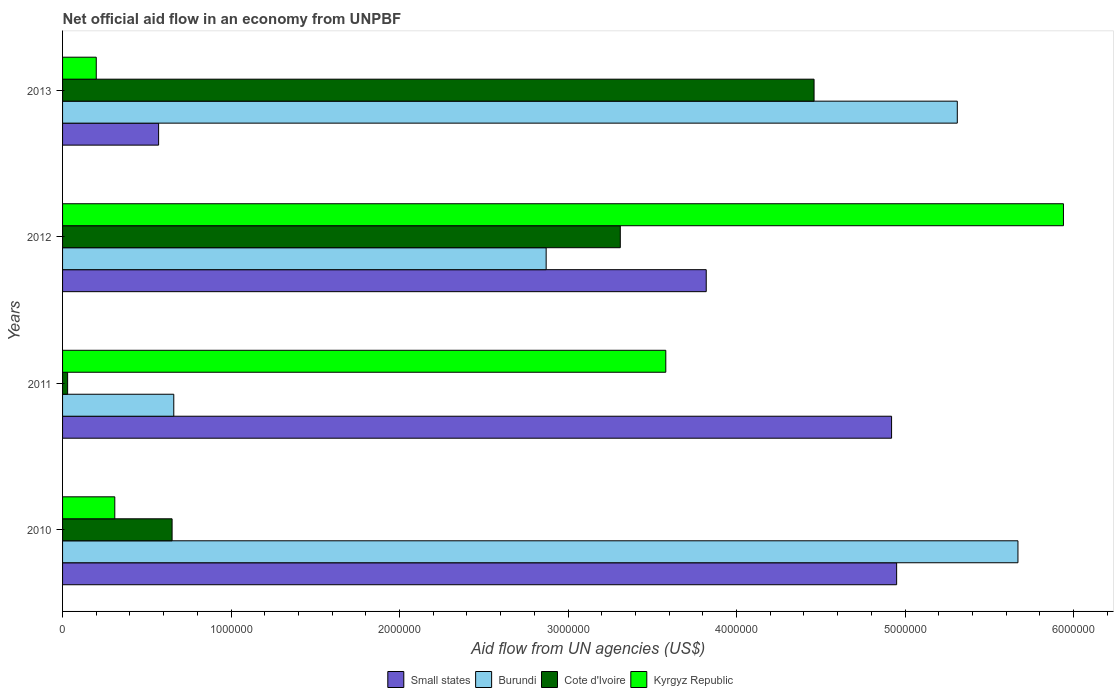How many different coloured bars are there?
Ensure brevity in your answer.  4. Are the number of bars on each tick of the Y-axis equal?
Offer a very short reply. Yes. In how many cases, is the number of bars for a given year not equal to the number of legend labels?
Give a very brief answer. 0. What is the net official aid flow in Burundi in 2012?
Offer a terse response. 2.87e+06. Across all years, what is the maximum net official aid flow in Kyrgyz Republic?
Provide a succinct answer. 5.94e+06. Across all years, what is the minimum net official aid flow in Small states?
Make the answer very short. 5.70e+05. In which year was the net official aid flow in Kyrgyz Republic maximum?
Make the answer very short. 2012. What is the total net official aid flow in Cote d'Ivoire in the graph?
Your answer should be compact. 8.45e+06. What is the difference between the net official aid flow in Cote d'Ivoire in 2010 and that in 2012?
Your answer should be very brief. -2.66e+06. What is the difference between the net official aid flow in Kyrgyz Republic in 2011 and the net official aid flow in Burundi in 2013?
Your answer should be very brief. -1.73e+06. What is the average net official aid flow in Burundi per year?
Your answer should be compact. 3.63e+06. In the year 2012, what is the difference between the net official aid flow in Cote d'Ivoire and net official aid flow in Burundi?
Provide a short and direct response. 4.40e+05. What is the ratio of the net official aid flow in Burundi in 2010 to that in 2012?
Your answer should be compact. 1.98. Is the net official aid flow in Small states in 2010 less than that in 2013?
Provide a succinct answer. No. What is the difference between the highest and the lowest net official aid flow in Cote d'Ivoire?
Offer a very short reply. 4.43e+06. In how many years, is the net official aid flow in Small states greater than the average net official aid flow in Small states taken over all years?
Ensure brevity in your answer.  3. Is the sum of the net official aid flow in Kyrgyz Republic in 2011 and 2013 greater than the maximum net official aid flow in Cote d'Ivoire across all years?
Offer a very short reply. No. Is it the case that in every year, the sum of the net official aid flow in Kyrgyz Republic and net official aid flow in Small states is greater than the sum of net official aid flow in Cote d'Ivoire and net official aid flow in Burundi?
Your answer should be compact. No. What does the 4th bar from the top in 2012 represents?
Make the answer very short. Small states. What does the 2nd bar from the bottom in 2012 represents?
Give a very brief answer. Burundi. What is the difference between two consecutive major ticks on the X-axis?
Provide a short and direct response. 1.00e+06. Are the values on the major ticks of X-axis written in scientific E-notation?
Keep it short and to the point. No. Does the graph contain grids?
Your answer should be compact. No. How are the legend labels stacked?
Offer a terse response. Horizontal. What is the title of the graph?
Your answer should be very brief. Net official aid flow in an economy from UNPBF. Does "Mali" appear as one of the legend labels in the graph?
Give a very brief answer. No. What is the label or title of the X-axis?
Your answer should be compact. Aid flow from UN agencies (US$). What is the label or title of the Y-axis?
Provide a short and direct response. Years. What is the Aid flow from UN agencies (US$) of Small states in 2010?
Your response must be concise. 4.95e+06. What is the Aid flow from UN agencies (US$) in Burundi in 2010?
Give a very brief answer. 5.67e+06. What is the Aid flow from UN agencies (US$) of Cote d'Ivoire in 2010?
Provide a succinct answer. 6.50e+05. What is the Aid flow from UN agencies (US$) of Small states in 2011?
Provide a succinct answer. 4.92e+06. What is the Aid flow from UN agencies (US$) of Burundi in 2011?
Give a very brief answer. 6.60e+05. What is the Aid flow from UN agencies (US$) in Kyrgyz Republic in 2011?
Provide a succinct answer. 3.58e+06. What is the Aid flow from UN agencies (US$) of Small states in 2012?
Your answer should be very brief. 3.82e+06. What is the Aid flow from UN agencies (US$) in Burundi in 2012?
Offer a terse response. 2.87e+06. What is the Aid flow from UN agencies (US$) in Cote d'Ivoire in 2012?
Offer a terse response. 3.31e+06. What is the Aid flow from UN agencies (US$) of Kyrgyz Republic in 2012?
Your answer should be very brief. 5.94e+06. What is the Aid flow from UN agencies (US$) of Small states in 2013?
Ensure brevity in your answer.  5.70e+05. What is the Aid flow from UN agencies (US$) in Burundi in 2013?
Provide a succinct answer. 5.31e+06. What is the Aid flow from UN agencies (US$) of Cote d'Ivoire in 2013?
Ensure brevity in your answer.  4.46e+06. What is the Aid flow from UN agencies (US$) in Kyrgyz Republic in 2013?
Keep it short and to the point. 2.00e+05. Across all years, what is the maximum Aid flow from UN agencies (US$) of Small states?
Offer a very short reply. 4.95e+06. Across all years, what is the maximum Aid flow from UN agencies (US$) in Burundi?
Your response must be concise. 5.67e+06. Across all years, what is the maximum Aid flow from UN agencies (US$) of Cote d'Ivoire?
Offer a terse response. 4.46e+06. Across all years, what is the maximum Aid flow from UN agencies (US$) of Kyrgyz Republic?
Offer a very short reply. 5.94e+06. Across all years, what is the minimum Aid flow from UN agencies (US$) in Small states?
Make the answer very short. 5.70e+05. Across all years, what is the minimum Aid flow from UN agencies (US$) in Burundi?
Your answer should be very brief. 6.60e+05. Across all years, what is the minimum Aid flow from UN agencies (US$) of Cote d'Ivoire?
Your answer should be compact. 3.00e+04. What is the total Aid flow from UN agencies (US$) in Small states in the graph?
Ensure brevity in your answer.  1.43e+07. What is the total Aid flow from UN agencies (US$) in Burundi in the graph?
Make the answer very short. 1.45e+07. What is the total Aid flow from UN agencies (US$) in Cote d'Ivoire in the graph?
Your answer should be very brief. 8.45e+06. What is the total Aid flow from UN agencies (US$) in Kyrgyz Republic in the graph?
Offer a very short reply. 1.00e+07. What is the difference between the Aid flow from UN agencies (US$) of Small states in 2010 and that in 2011?
Provide a short and direct response. 3.00e+04. What is the difference between the Aid flow from UN agencies (US$) of Burundi in 2010 and that in 2011?
Offer a terse response. 5.01e+06. What is the difference between the Aid flow from UN agencies (US$) in Cote d'Ivoire in 2010 and that in 2011?
Provide a succinct answer. 6.20e+05. What is the difference between the Aid flow from UN agencies (US$) in Kyrgyz Republic in 2010 and that in 2011?
Your response must be concise. -3.27e+06. What is the difference between the Aid flow from UN agencies (US$) of Small states in 2010 and that in 2012?
Ensure brevity in your answer.  1.13e+06. What is the difference between the Aid flow from UN agencies (US$) in Burundi in 2010 and that in 2012?
Offer a terse response. 2.80e+06. What is the difference between the Aid flow from UN agencies (US$) of Cote d'Ivoire in 2010 and that in 2012?
Keep it short and to the point. -2.66e+06. What is the difference between the Aid flow from UN agencies (US$) in Kyrgyz Republic in 2010 and that in 2012?
Ensure brevity in your answer.  -5.63e+06. What is the difference between the Aid flow from UN agencies (US$) in Small states in 2010 and that in 2013?
Offer a terse response. 4.38e+06. What is the difference between the Aid flow from UN agencies (US$) in Cote d'Ivoire in 2010 and that in 2013?
Offer a very short reply. -3.81e+06. What is the difference between the Aid flow from UN agencies (US$) of Kyrgyz Republic in 2010 and that in 2013?
Offer a very short reply. 1.10e+05. What is the difference between the Aid flow from UN agencies (US$) in Small states in 2011 and that in 2012?
Your answer should be compact. 1.10e+06. What is the difference between the Aid flow from UN agencies (US$) of Burundi in 2011 and that in 2012?
Your answer should be very brief. -2.21e+06. What is the difference between the Aid flow from UN agencies (US$) of Cote d'Ivoire in 2011 and that in 2012?
Your answer should be very brief. -3.28e+06. What is the difference between the Aid flow from UN agencies (US$) of Kyrgyz Republic in 2011 and that in 2012?
Your answer should be very brief. -2.36e+06. What is the difference between the Aid flow from UN agencies (US$) in Small states in 2011 and that in 2013?
Provide a succinct answer. 4.35e+06. What is the difference between the Aid flow from UN agencies (US$) in Burundi in 2011 and that in 2013?
Ensure brevity in your answer.  -4.65e+06. What is the difference between the Aid flow from UN agencies (US$) in Cote d'Ivoire in 2011 and that in 2013?
Your response must be concise. -4.43e+06. What is the difference between the Aid flow from UN agencies (US$) in Kyrgyz Republic in 2011 and that in 2013?
Offer a terse response. 3.38e+06. What is the difference between the Aid flow from UN agencies (US$) of Small states in 2012 and that in 2013?
Provide a succinct answer. 3.25e+06. What is the difference between the Aid flow from UN agencies (US$) of Burundi in 2012 and that in 2013?
Make the answer very short. -2.44e+06. What is the difference between the Aid flow from UN agencies (US$) in Cote d'Ivoire in 2012 and that in 2013?
Give a very brief answer. -1.15e+06. What is the difference between the Aid flow from UN agencies (US$) in Kyrgyz Republic in 2012 and that in 2013?
Your response must be concise. 5.74e+06. What is the difference between the Aid flow from UN agencies (US$) in Small states in 2010 and the Aid flow from UN agencies (US$) in Burundi in 2011?
Your answer should be very brief. 4.29e+06. What is the difference between the Aid flow from UN agencies (US$) of Small states in 2010 and the Aid flow from UN agencies (US$) of Cote d'Ivoire in 2011?
Your answer should be very brief. 4.92e+06. What is the difference between the Aid flow from UN agencies (US$) of Small states in 2010 and the Aid flow from UN agencies (US$) of Kyrgyz Republic in 2011?
Your answer should be compact. 1.37e+06. What is the difference between the Aid flow from UN agencies (US$) of Burundi in 2010 and the Aid flow from UN agencies (US$) of Cote d'Ivoire in 2011?
Keep it short and to the point. 5.64e+06. What is the difference between the Aid flow from UN agencies (US$) of Burundi in 2010 and the Aid flow from UN agencies (US$) of Kyrgyz Republic in 2011?
Provide a succinct answer. 2.09e+06. What is the difference between the Aid flow from UN agencies (US$) of Cote d'Ivoire in 2010 and the Aid flow from UN agencies (US$) of Kyrgyz Republic in 2011?
Offer a very short reply. -2.93e+06. What is the difference between the Aid flow from UN agencies (US$) in Small states in 2010 and the Aid flow from UN agencies (US$) in Burundi in 2012?
Offer a terse response. 2.08e+06. What is the difference between the Aid flow from UN agencies (US$) in Small states in 2010 and the Aid flow from UN agencies (US$) in Cote d'Ivoire in 2012?
Keep it short and to the point. 1.64e+06. What is the difference between the Aid flow from UN agencies (US$) of Small states in 2010 and the Aid flow from UN agencies (US$) of Kyrgyz Republic in 2012?
Offer a very short reply. -9.90e+05. What is the difference between the Aid flow from UN agencies (US$) in Burundi in 2010 and the Aid flow from UN agencies (US$) in Cote d'Ivoire in 2012?
Provide a succinct answer. 2.36e+06. What is the difference between the Aid flow from UN agencies (US$) in Burundi in 2010 and the Aid flow from UN agencies (US$) in Kyrgyz Republic in 2012?
Provide a short and direct response. -2.70e+05. What is the difference between the Aid flow from UN agencies (US$) in Cote d'Ivoire in 2010 and the Aid flow from UN agencies (US$) in Kyrgyz Republic in 2012?
Make the answer very short. -5.29e+06. What is the difference between the Aid flow from UN agencies (US$) in Small states in 2010 and the Aid flow from UN agencies (US$) in Burundi in 2013?
Your response must be concise. -3.60e+05. What is the difference between the Aid flow from UN agencies (US$) of Small states in 2010 and the Aid flow from UN agencies (US$) of Cote d'Ivoire in 2013?
Make the answer very short. 4.90e+05. What is the difference between the Aid flow from UN agencies (US$) of Small states in 2010 and the Aid flow from UN agencies (US$) of Kyrgyz Republic in 2013?
Keep it short and to the point. 4.75e+06. What is the difference between the Aid flow from UN agencies (US$) of Burundi in 2010 and the Aid flow from UN agencies (US$) of Cote d'Ivoire in 2013?
Provide a succinct answer. 1.21e+06. What is the difference between the Aid flow from UN agencies (US$) in Burundi in 2010 and the Aid flow from UN agencies (US$) in Kyrgyz Republic in 2013?
Keep it short and to the point. 5.47e+06. What is the difference between the Aid flow from UN agencies (US$) of Small states in 2011 and the Aid flow from UN agencies (US$) of Burundi in 2012?
Make the answer very short. 2.05e+06. What is the difference between the Aid flow from UN agencies (US$) of Small states in 2011 and the Aid flow from UN agencies (US$) of Cote d'Ivoire in 2012?
Give a very brief answer. 1.61e+06. What is the difference between the Aid flow from UN agencies (US$) in Small states in 2011 and the Aid flow from UN agencies (US$) in Kyrgyz Republic in 2012?
Provide a succinct answer. -1.02e+06. What is the difference between the Aid flow from UN agencies (US$) in Burundi in 2011 and the Aid flow from UN agencies (US$) in Cote d'Ivoire in 2012?
Provide a short and direct response. -2.65e+06. What is the difference between the Aid flow from UN agencies (US$) in Burundi in 2011 and the Aid flow from UN agencies (US$) in Kyrgyz Republic in 2012?
Your response must be concise. -5.28e+06. What is the difference between the Aid flow from UN agencies (US$) of Cote d'Ivoire in 2011 and the Aid flow from UN agencies (US$) of Kyrgyz Republic in 2012?
Your answer should be compact. -5.91e+06. What is the difference between the Aid flow from UN agencies (US$) of Small states in 2011 and the Aid flow from UN agencies (US$) of Burundi in 2013?
Make the answer very short. -3.90e+05. What is the difference between the Aid flow from UN agencies (US$) of Small states in 2011 and the Aid flow from UN agencies (US$) of Cote d'Ivoire in 2013?
Give a very brief answer. 4.60e+05. What is the difference between the Aid flow from UN agencies (US$) in Small states in 2011 and the Aid flow from UN agencies (US$) in Kyrgyz Republic in 2013?
Provide a short and direct response. 4.72e+06. What is the difference between the Aid flow from UN agencies (US$) in Burundi in 2011 and the Aid flow from UN agencies (US$) in Cote d'Ivoire in 2013?
Offer a terse response. -3.80e+06. What is the difference between the Aid flow from UN agencies (US$) in Cote d'Ivoire in 2011 and the Aid flow from UN agencies (US$) in Kyrgyz Republic in 2013?
Make the answer very short. -1.70e+05. What is the difference between the Aid flow from UN agencies (US$) of Small states in 2012 and the Aid flow from UN agencies (US$) of Burundi in 2013?
Your answer should be very brief. -1.49e+06. What is the difference between the Aid flow from UN agencies (US$) of Small states in 2012 and the Aid flow from UN agencies (US$) of Cote d'Ivoire in 2013?
Your answer should be compact. -6.40e+05. What is the difference between the Aid flow from UN agencies (US$) of Small states in 2012 and the Aid flow from UN agencies (US$) of Kyrgyz Republic in 2013?
Your response must be concise. 3.62e+06. What is the difference between the Aid flow from UN agencies (US$) of Burundi in 2012 and the Aid flow from UN agencies (US$) of Cote d'Ivoire in 2013?
Provide a short and direct response. -1.59e+06. What is the difference between the Aid flow from UN agencies (US$) in Burundi in 2012 and the Aid flow from UN agencies (US$) in Kyrgyz Republic in 2013?
Offer a very short reply. 2.67e+06. What is the difference between the Aid flow from UN agencies (US$) in Cote d'Ivoire in 2012 and the Aid flow from UN agencies (US$) in Kyrgyz Republic in 2013?
Offer a very short reply. 3.11e+06. What is the average Aid flow from UN agencies (US$) of Small states per year?
Offer a very short reply. 3.56e+06. What is the average Aid flow from UN agencies (US$) in Burundi per year?
Keep it short and to the point. 3.63e+06. What is the average Aid flow from UN agencies (US$) in Cote d'Ivoire per year?
Your answer should be very brief. 2.11e+06. What is the average Aid flow from UN agencies (US$) in Kyrgyz Republic per year?
Your answer should be very brief. 2.51e+06. In the year 2010, what is the difference between the Aid flow from UN agencies (US$) in Small states and Aid flow from UN agencies (US$) in Burundi?
Provide a succinct answer. -7.20e+05. In the year 2010, what is the difference between the Aid flow from UN agencies (US$) in Small states and Aid flow from UN agencies (US$) in Cote d'Ivoire?
Offer a very short reply. 4.30e+06. In the year 2010, what is the difference between the Aid flow from UN agencies (US$) of Small states and Aid flow from UN agencies (US$) of Kyrgyz Republic?
Your answer should be very brief. 4.64e+06. In the year 2010, what is the difference between the Aid flow from UN agencies (US$) of Burundi and Aid flow from UN agencies (US$) of Cote d'Ivoire?
Offer a terse response. 5.02e+06. In the year 2010, what is the difference between the Aid flow from UN agencies (US$) of Burundi and Aid flow from UN agencies (US$) of Kyrgyz Republic?
Give a very brief answer. 5.36e+06. In the year 2011, what is the difference between the Aid flow from UN agencies (US$) in Small states and Aid flow from UN agencies (US$) in Burundi?
Provide a succinct answer. 4.26e+06. In the year 2011, what is the difference between the Aid flow from UN agencies (US$) in Small states and Aid flow from UN agencies (US$) in Cote d'Ivoire?
Ensure brevity in your answer.  4.89e+06. In the year 2011, what is the difference between the Aid flow from UN agencies (US$) in Small states and Aid flow from UN agencies (US$) in Kyrgyz Republic?
Give a very brief answer. 1.34e+06. In the year 2011, what is the difference between the Aid flow from UN agencies (US$) of Burundi and Aid flow from UN agencies (US$) of Cote d'Ivoire?
Offer a terse response. 6.30e+05. In the year 2011, what is the difference between the Aid flow from UN agencies (US$) in Burundi and Aid flow from UN agencies (US$) in Kyrgyz Republic?
Offer a terse response. -2.92e+06. In the year 2011, what is the difference between the Aid flow from UN agencies (US$) of Cote d'Ivoire and Aid flow from UN agencies (US$) of Kyrgyz Republic?
Ensure brevity in your answer.  -3.55e+06. In the year 2012, what is the difference between the Aid flow from UN agencies (US$) in Small states and Aid flow from UN agencies (US$) in Burundi?
Your answer should be very brief. 9.50e+05. In the year 2012, what is the difference between the Aid flow from UN agencies (US$) in Small states and Aid flow from UN agencies (US$) in Cote d'Ivoire?
Your answer should be compact. 5.10e+05. In the year 2012, what is the difference between the Aid flow from UN agencies (US$) of Small states and Aid flow from UN agencies (US$) of Kyrgyz Republic?
Your answer should be very brief. -2.12e+06. In the year 2012, what is the difference between the Aid flow from UN agencies (US$) in Burundi and Aid flow from UN agencies (US$) in Cote d'Ivoire?
Offer a terse response. -4.40e+05. In the year 2012, what is the difference between the Aid flow from UN agencies (US$) in Burundi and Aid flow from UN agencies (US$) in Kyrgyz Republic?
Provide a succinct answer. -3.07e+06. In the year 2012, what is the difference between the Aid flow from UN agencies (US$) of Cote d'Ivoire and Aid flow from UN agencies (US$) of Kyrgyz Republic?
Provide a succinct answer. -2.63e+06. In the year 2013, what is the difference between the Aid flow from UN agencies (US$) of Small states and Aid flow from UN agencies (US$) of Burundi?
Your answer should be compact. -4.74e+06. In the year 2013, what is the difference between the Aid flow from UN agencies (US$) of Small states and Aid flow from UN agencies (US$) of Cote d'Ivoire?
Offer a very short reply. -3.89e+06. In the year 2013, what is the difference between the Aid flow from UN agencies (US$) of Burundi and Aid flow from UN agencies (US$) of Cote d'Ivoire?
Give a very brief answer. 8.50e+05. In the year 2013, what is the difference between the Aid flow from UN agencies (US$) in Burundi and Aid flow from UN agencies (US$) in Kyrgyz Republic?
Your answer should be compact. 5.11e+06. In the year 2013, what is the difference between the Aid flow from UN agencies (US$) of Cote d'Ivoire and Aid flow from UN agencies (US$) of Kyrgyz Republic?
Provide a short and direct response. 4.26e+06. What is the ratio of the Aid flow from UN agencies (US$) in Small states in 2010 to that in 2011?
Provide a short and direct response. 1.01. What is the ratio of the Aid flow from UN agencies (US$) in Burundi in 2010 to that in 2011?
Your answer should be compact. 8.59. What is the ratio of the Aid flow from UN agencies (US$) of Cote d'Ivoire in 2010 to that in 2011?
Offer a very short reply. 21.67. What is the ratio of the Aid flow from UN agencies (US$) of Kyrgyz Republic in 2010 to that in 2011?
Provide a succinct answer. 0.09. What is the ratio of the Aid flow from UN agencies (US$) of Small states in 2010 to that in 2012?
Your answer should be compact. 1.3. What is the ratio of the Aid flow from UN agencies (US$) of Burundi in 2010 to that in 2012?
Make the answer very short. 1.98. What is the ratio of the Aid flow from UN agencies (US$) in Cote d'Ivoire in 2010 to that in 2012?
Your answer should be very brief. 0.2. What is the ratio of the Aid flow from UN agencies (US$) of Kyrgyz Republic in 2010 to that in 2012?
Your answer should be very brief. 0.05. What is the ratio of the Aid flow from UN agencies (US$) in Small states in 2010 to that in 2013?
Your answer should be very brief. 8.68. What is the ratio of the Aid flow from UN agencies (US$) of Burundi in 2010 to that in 2013?
Your answer should be very brief. 1.07. What is the ratio of the Aid flow from UN agencies (US$) of Cote d'Ivoire in 2010 to that in 2013?
Provide a short and direct response. 0.15. What is the ratio of the Aid flow from UN agencies (US$) in Kyrgyz Republic in 2010 to that in 2013?
Provide a short and direct response. 1.55. What is the ratio of the Aid flow from UN agencies (US$) in Small states in 2011 to that in 2012?
Provide a short and direct response. 1.29. What is the ratio of the Aid flow from UN agencies (US$) in Burundi in 2011 to that in 2012?
Your answer should be compact. 0.23. What is the ratio of the Aid flow from UN agencies (US$) of Cote d'Ivoire in 2011 to that in 2012?
Offer a very short reply. 0.01. What is the ratio of the Aid flow from UN agencies (US$) of Kyrgyz Republic in 2011 to that in 2012?
Your answer should be compact. 0.6. What is the ratio of the Aid flow from UN agencies (US$) in Small states in 2011 to that in 2013?
Your response must be concise. 8.63. What is the ratio of the Aid flow from UN agencies (US$) in Burundi in 2011 to that in 2013?
Ensure brevity in your answer.  0.12. What is the ratio of the Aid flow from UN agencies (US$) in Cote d'Ivoire in 2011 to that in 2013?
Keep it short and to the point. 0.01. What is the ratio of the Aid flow from UN agencies (US$) of Small states in 2012 to that in 2013?
Provide a short and direct response. 6.7. What is the ratio of the Aid flow from UN agencies (US$) in Burundi in 2012 to that in 2013?
Offer a terse response. 0.54. What is the ratio of the Aid flow from UN agencies (US$) of Cote d'Ivoire in 2012 to that in 2013?
Your response must be concise. 0.74. What is the ratio of the Aid flow from UN agencies (US$) of Kyrgyz Republic in 2012 to that in 2013?
Provide a succinct answer. 29.7. What is the difference between the highest and the second highest Aid flow from UN agencies (US$) of Small states?
Keep it short and to the point. 3.00e+04. What is the difference between the highest and the second highest Aid flow from UN agencies (US$) in Burundi?
Offer a terse response. 3.60e+05. What is the difference between the highest and the second highest Aid flow from UN agencies (US$) of Cote d'Ivoire?
Offer a very short reply. 1.15e+06. What is the difference between the highest and the second highest Aid flow from UN agencies (US$) of Kyrgyz Republic?
Your answer should be very brief. 2.36e+06. What is the difference between the highest and the lowest Aid flow from UN agencies (US$) of Small states?
Your answer should be compact. 4.38e+06. What is the difference between the highest and the lowest Aid flow from UN agencies (US$) of Burundi?
Your answer should be compact. 5.01e+06. What is the difference between the highest and the lowest Aid flow from UN agencies (US$) in Cote d'Ivoire?
Ensure brevity in your answer.  4.43e+06. What is the difference between the highest and the lowest Aid flow from UN agencies (US$) of Kyrgyz Republic?
Offer a terse response. 5.74e+06. 